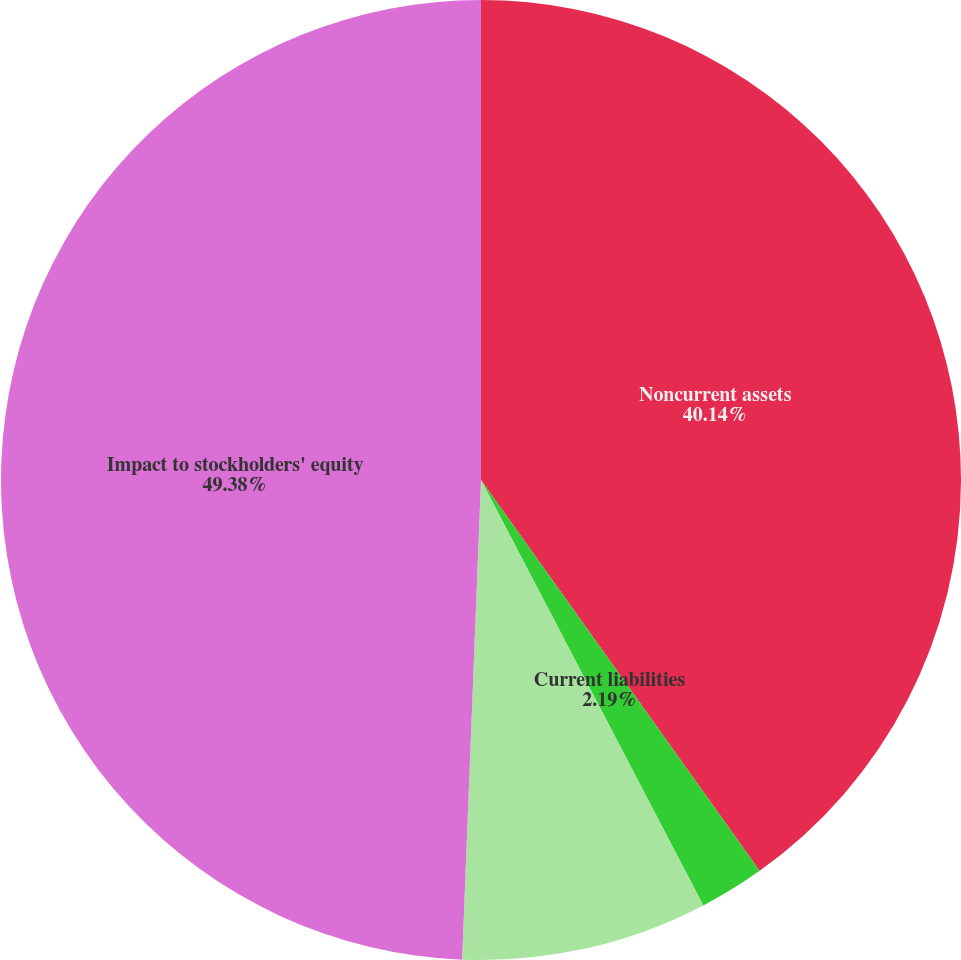Convert chart to OTSL. <chart><loc_0><loc_0><loc_500><loc_500><pie_chart><fcel>Noncurrent assets<fcel>Current liabilities<fcel>Noncurrent liabilities<fcel>Impact to stockholders' equity<nl><fcel>40.14%<fcel>2.19%<fcel>8.29%<fcel>49.37%<nl></chart> 